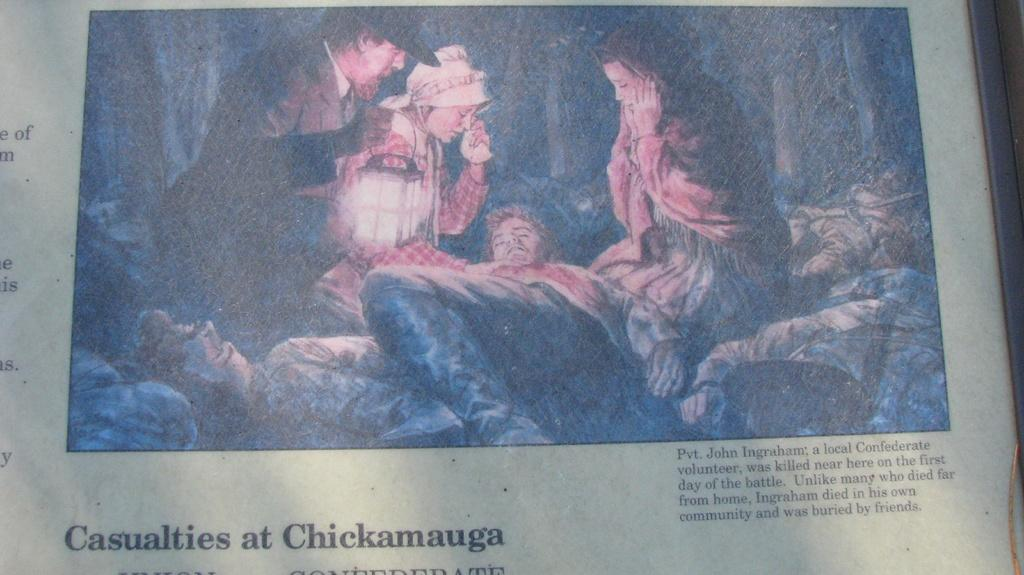What object is present in the image that typically holds a photograph? There is a photo frame in the image. What can be seen on the photo frame besides the image of the group of people? There are words on the photo frame. What type of image is displayed on the photo frame? There is an image of a group of people on the photo frame. Where is the throne located in the image? There is no throne present in the image. What type of button can be seen on the cave in the image? There is no cave or button present in the image. 